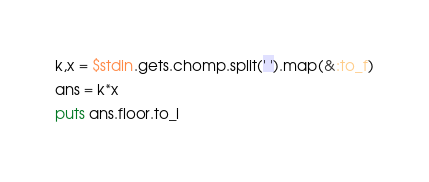Convert code to text. <code><loc_0><loc_0><loc_500><loc_500><_Ruby_>k,x = $stdin.gets.chomp.split(' ').map(&:to_f)
ans = k*x
puts ans.floor.to_i
</code> 